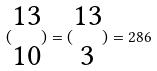Convert formula to latex. <formula><loc_0><loc_0><loc_500><loc_500>( \begin{matrix} 1 3 \\ 1 0 \end{matrix} ) = ( \begin{matrix} 1 3 \\ 3 \end{matrix} ) = 2 8 6</formula> 